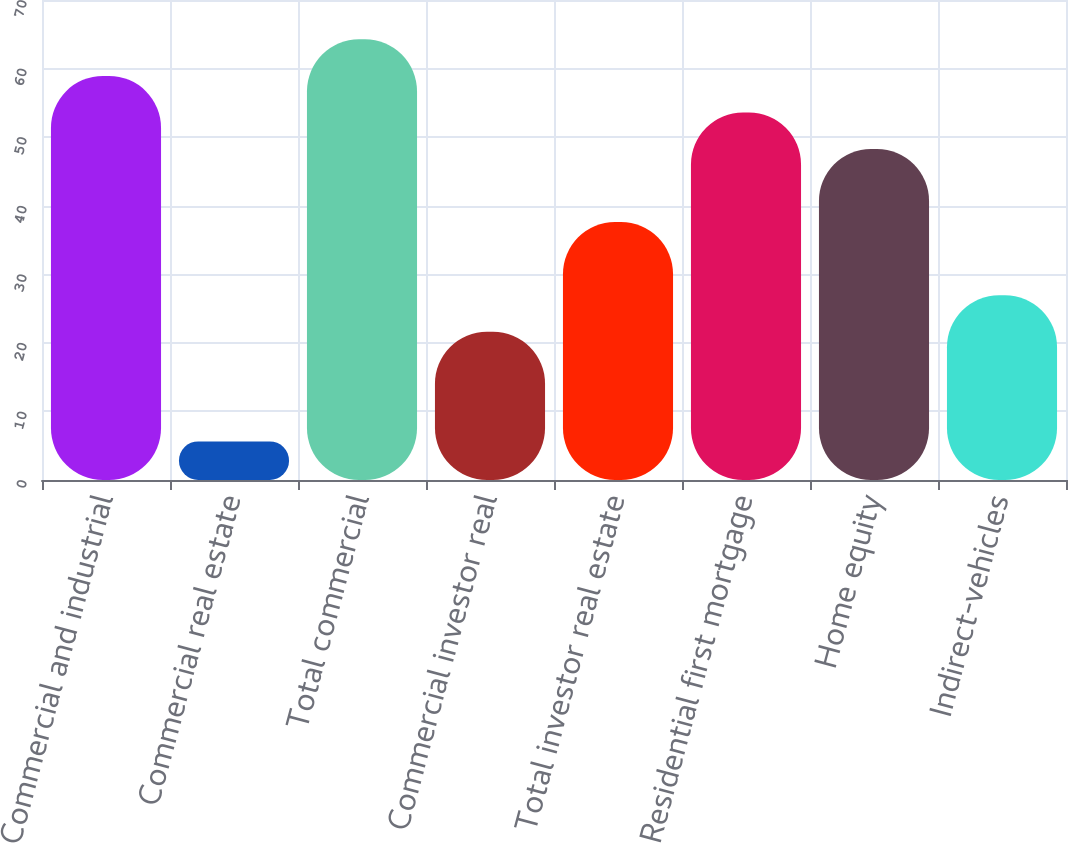Convert chart. <chart><loc_0><loc_0><loc_500><loc_500><bar_chart><fcel>Commercial and industrial<fcel>Commercial real estate<fcel>Total commercial<fcel>Commercial investor real<fcel>Total investor real estate<fcel>Residential first mortgage<fcel>Home equity<fcel>Indirect-vehicles<nl><fcel>58.93<fcel>5.63<fcel>64.26<fcel>21.62<fcel>37.61<fcel>53.6<fcel>48.27<fcel>26.95<nl></chart> 